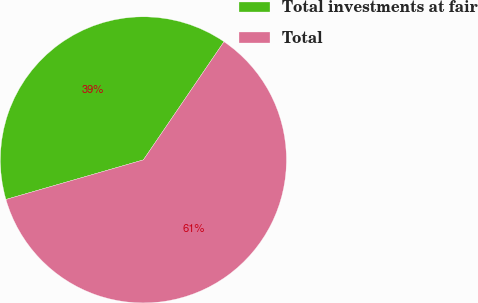<chart> <loc_0><loc_0><loc_500><loc_500><pie_chart><fcel>Total investments at fair<fcel>Total<nl><fcel>38.99%<fcel>61.01%<nl></chart> 